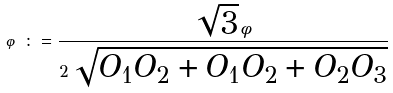<formula> <loc_0><loc_0><loc_500><loc_500>\varphi \colon = \frac { \sqrt { 3 } \, \phi } { 2 \, \sqrt { O _ { 1 } O _ { 2 } + O _ { 1 } O _ { 2 } + O _ { 2 } O _ { 3 } } }</formula> 